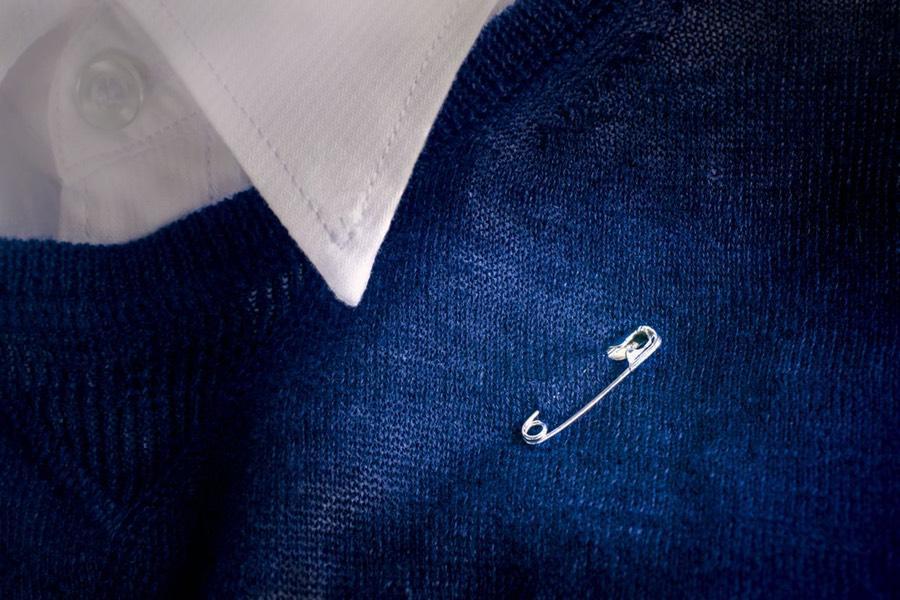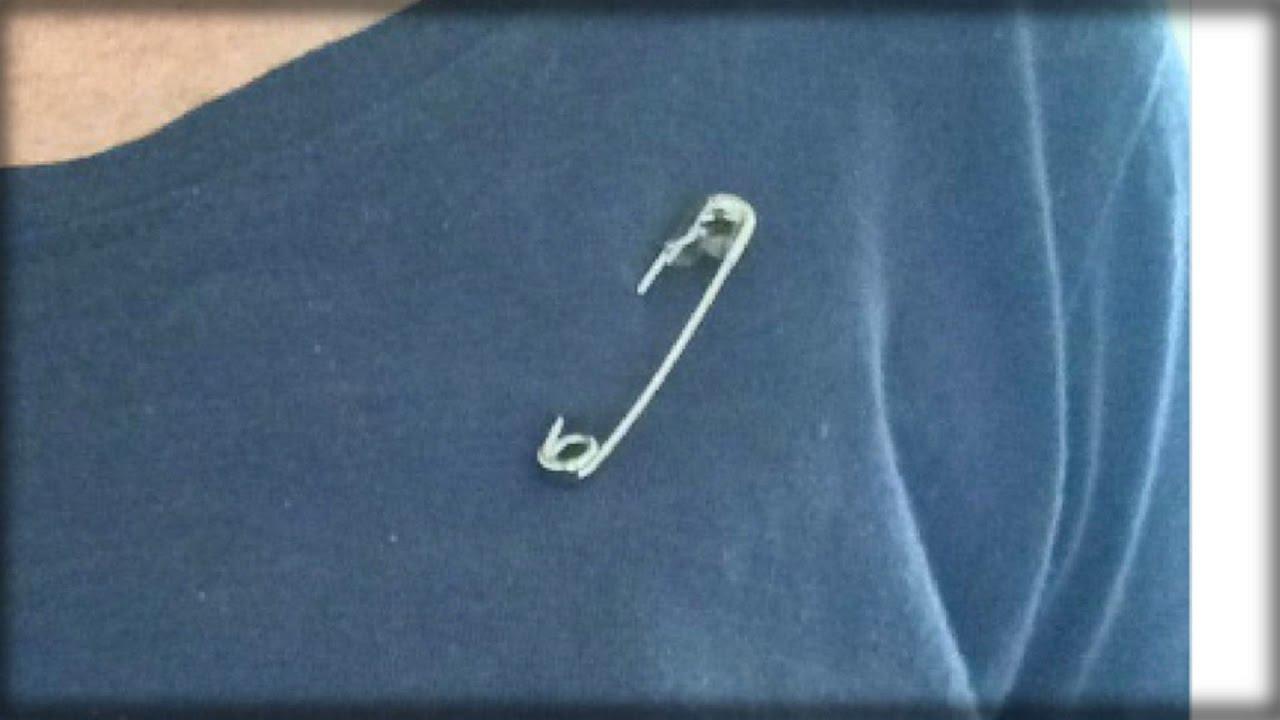The first image is the image on the left, the second image is the image on the right. Assess this claim about the two images: "There are three people saving the world by wearing safety pins.". Correct or not? Answer yes or no. No. The first image is the image on the left, the second image is the image on the right. Evaluate the accuracy of this statement regarding the images: "Each image shows a safety pin attached to someone's shirt, though no part of their head is visible.". Is it true? Answer yes or no. Yes. 